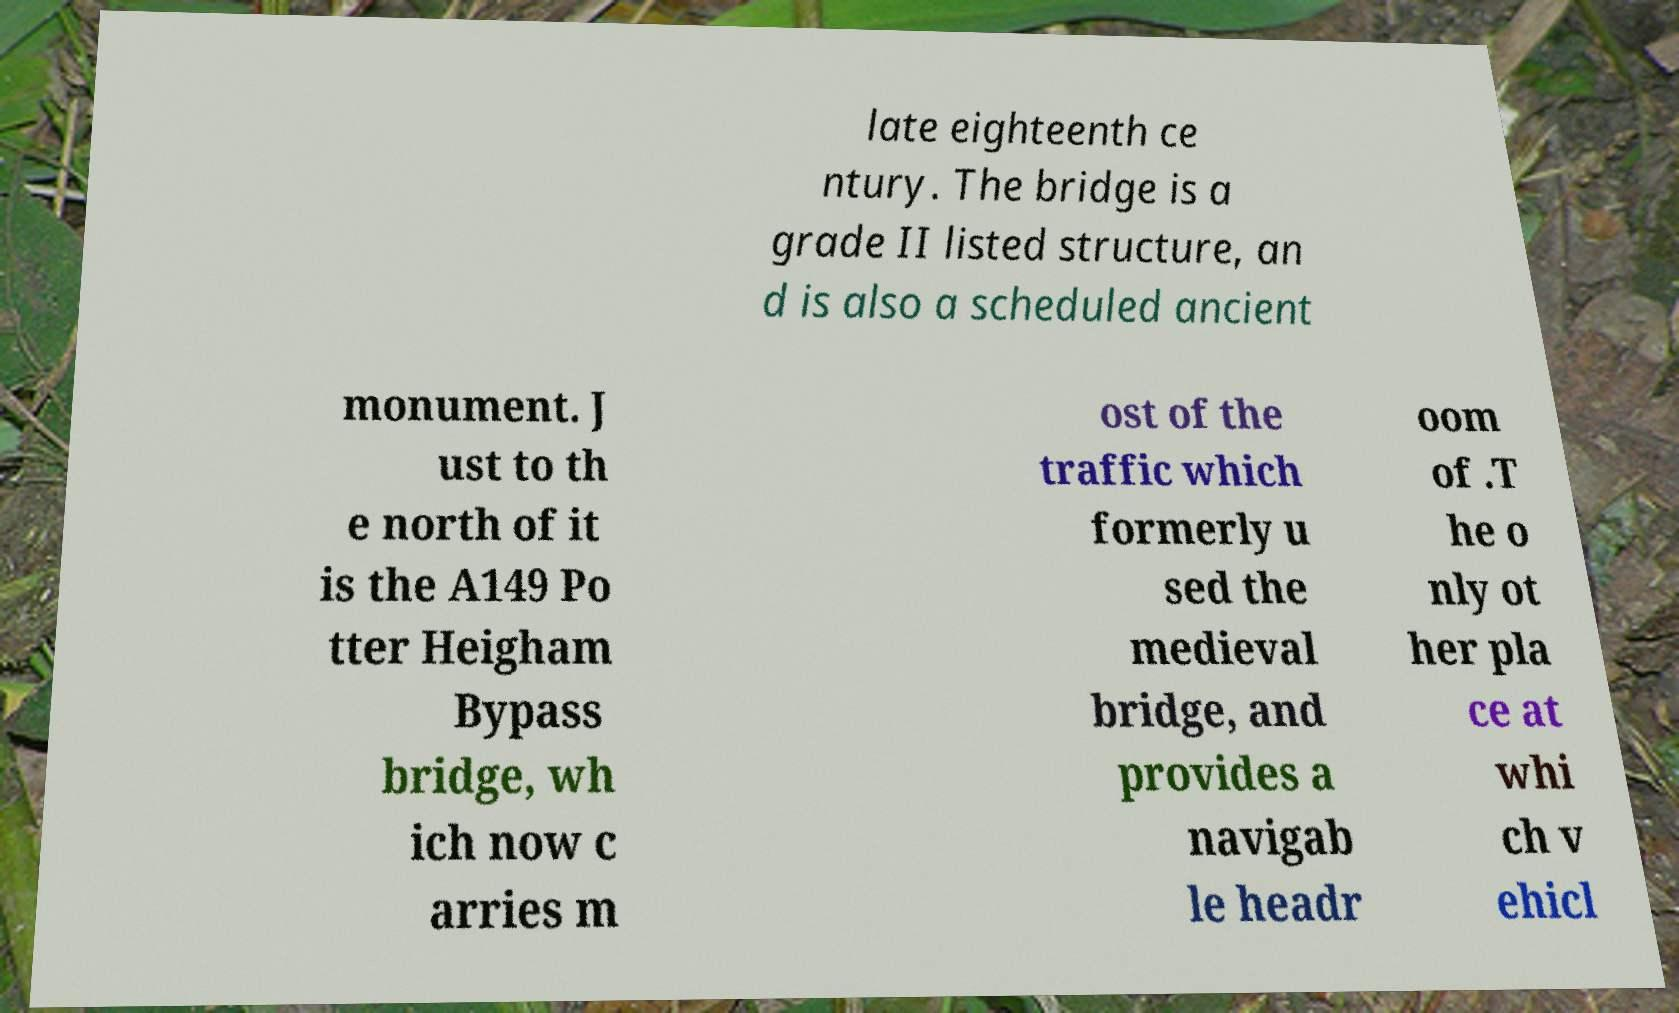I need the written content from this picture converted into text. Can you do that? late eighteenth ce ntury. The bridge is a grade II listed structure, an d is also a scheduled ancient monument. J ust to th e north of it is the A149 Po tter Heigham Bypass bridge, wh ich now c arries m ost of the traffic which formerly u sed the medieval bridge, and provides a navigab le headr oom of .T he o nly ot her pla ce at whi ch v ehicl 